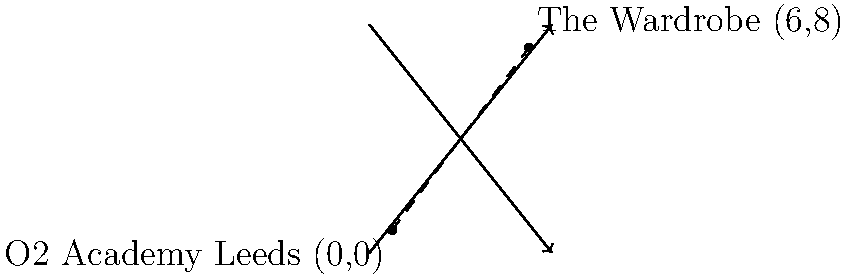As an up-and-coming guitarist in Leeds, you're planning a tour of local venues. You're currently at the O2 Academy Leeds, located at coordinates (0,0) on the city map. Your next gig is at The Wardrobe, which is at coordinates (6,8). Using the distance formula, calculate the straight-line distance between these two venues in map units. To solve this problem, we'll use the distance formula derived from the Pythagorean theorem:

$$d = \sqrt{(x_2-x_1)^2 + (y_2-y_1)^2}$$

Where $(x_1,y_1)$ is the coordinate of the first point and $(x_2,y_2)$ is the coordinate of the second point.

Step 1: Identify the coordinates
- O2 Academy Leeds: $(x_1,y_1) = (0,0)$
- The Wardrobe: $(x_2,y_2) = (6,8)$

Step 2: Plug the coordinates into the distance formula
$$d = \sqrt{(6-0)^2 + (8-0)^2}$$

Step 3: Simplify the expressions inside the parentheses
$$d = \sqrt{6^2 + 8^2}$$

Step 4: Calculate the squares
$$d = \sqrt{36 + 64}$$

Step 5: Add the numbers under the square root
$$d = \sqrt{100}$$

Step 6: Simplify the square root
$$d = 10$$

Therefore, the straight-line distance between the O2 Academy Leeds and The Wardrobe is 10 map units.
Answer: 10 map units 